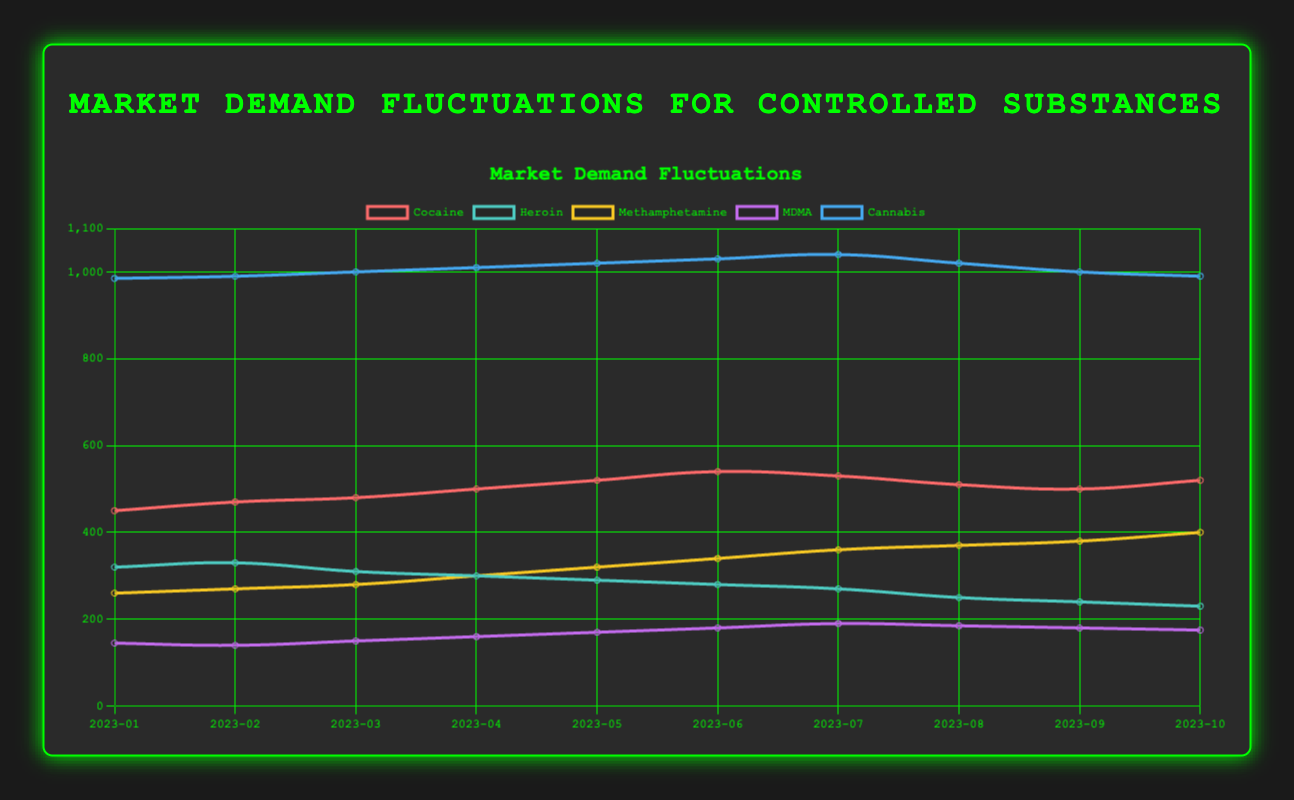What's the overall trend for the market demand of Cocaine from January to October 2023? The data show that the demand for Cocaine generally increases from January to June, reaching its peak in June at 540 units, and then fluctuates downward before slightly increasing again in October to 520 units.
Answer: Increasing, then fluctuating Which controlled substance showed a consistent decline in market demand from January to October 2023? By examining the trends, Heroin exhibits a consistent decline, starting at 320 units in January and dropping steadily to 230 units in October.
Answer: Heroin What’s the total market demand for Methamphetamine over the ten months? Summing the monthly demands for Methamphetamine: 260 + 270 + 280 + 300 + 320 + 340 + 360 + 370 + 380 + 400 = 3280.
Answer: 3280 Between MDMA and Cannabis, which has a higher market demand in May 2023? In May 2023, MDMA’s demand is 170 units, while Cannabis’s demand is 1020 units. Comparing these, Cannabis has a higher demand.
Answer: Cannabis Which substance had the maximum market demand in any given month, and in which month did this occur? Cannabis had the maximum market demand of 1040 units in July 2023.
Answer: Cannabis in July 2023 What's the average market demand for MDMA from January to October 2023? The total demand is 145 + 140 + 150 + 160 + 170 + 180 + 190 + 185 + 180 + 175 = 1675 and the average over 10 months is 1675 / 10 = 167.5.
Answer: 167.5 In which two consecutive months did Cocaine see the steepest decline in market demand? The largest consecutive drop for Cocaine happens between June (540 units) and July (530 units) which is a 10-unit decline.
Answer: June to July Comparing the highest and lowest demand for Methamphetamine, what's the difference? The highest demand for Methamphetamine is 400 units in October, and the lowest is 260 units in January, resulting in a difference of 400 - 260 = 140 units.
Answer: 140 What’s the combined market demand for all substances in February 2023? Summing the demands for February: Cocaine (470) + Heroin (330) + Methamphetamine (270) + MDMA (140) + Cannabis (990) = 2200.
Answer: 2200 When did MDMA experience its peak demand, and what was the value? Examining the chart, MDMA’s peak demand occurred in August 2023 at 190 units.
Answer: August 2023, 190 units 